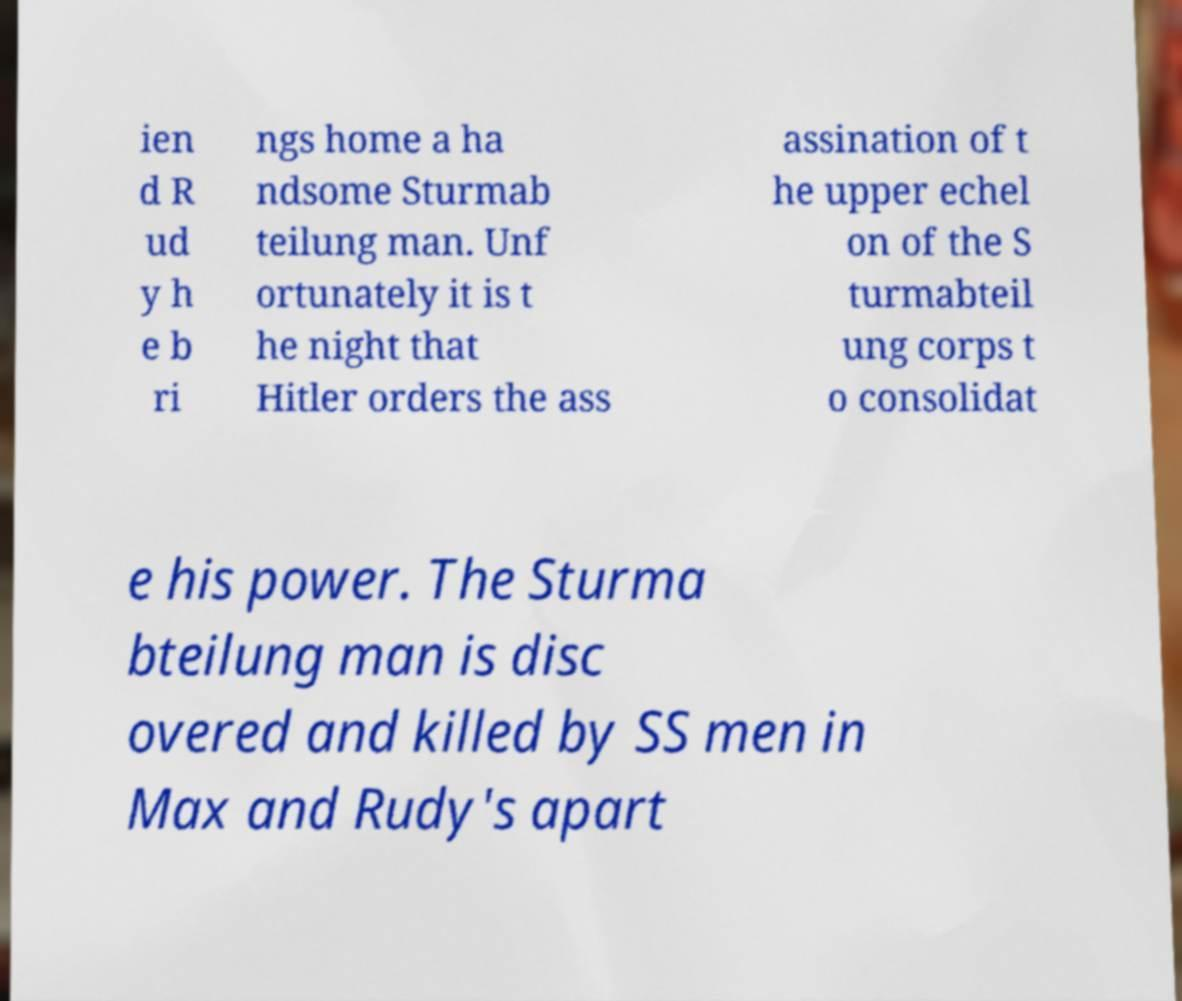Could you extract and type out the text from this image? ien d R ud y h e b ri ngs home a ha ndsome Sturmab teilung man. Unf ortunately it is t he night that Hitler orders the ass assination of t he upper echel on of the S turmabteil ung corps t o consolidat e his power. The Sturma bteilung man is disc overed and killed by SS men in Max and Rudy's apart 